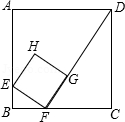In the square ABCD with side length 6.0, there is a small square EFGH, where E, F, and G are on AB, BC, and FD respectively. If BF = 1.5, how long is the side of the small square? To find the length of the side of the small square EFGH inside square ABCD, we start by calculating segment lengths. With the side length of the larger square being 6, and BF being 1.5, CF totals 4.5. By examining the similarity of triangles BFE and CFD, we derive that BE/4.5 = 1.5/6, which gives BE as 4.5/4 or 1.125. Using Pythagoras in triangle BEF, we find the side length EF of the smaller square EFGH: EF = sqrt((1.125)^2 + (1.5)^2) = 1.875. This demonstrates how geometry principles can be applied to solve related issues succinctly and accurately. 